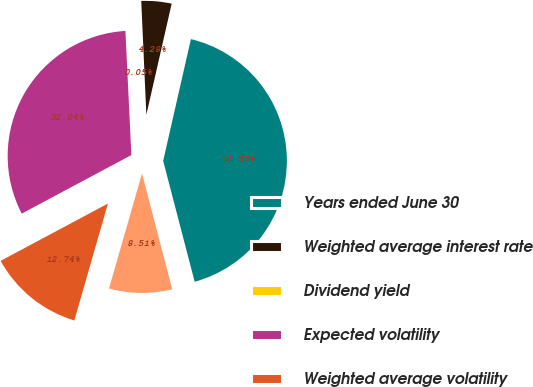Convert chart to OTSL. <chart><loc_0><loc_0><loc_500><loc_500><pie_chart><fcel>Years ended June 30<fcel>Weighted average interest rate<fcel>Dividend yield<fcel>Expected volatility<fcel>Weighted average volatility<fcel>Expected life in years<nl><fcel>42.37%<fcel>4.28%<fcel>0.05%<fcel>32.04%<fcel>12.74%<fcel>8.51%<nl></chart> 